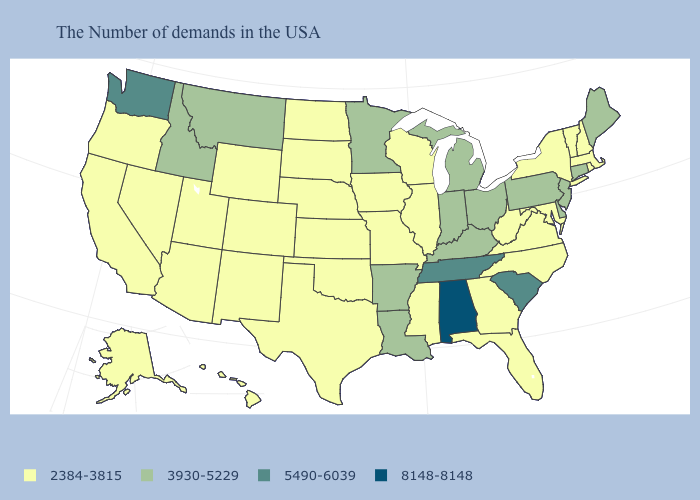What is the lowest value in the USA?
Short answer required. 2384-3815. What is the lowest value in states that border Idaho?
Concise answer only. 2384-3815. What is the value of South Dakota?
Concise answer only. 2384-3815. Name the states that have a value in the range 2384-3815?
Give a very brief answer. Massachusetts, Rhode Island, New Hampshire, Vermont, New York, Maryland, Virginia, North Carolina, West Virginia, Florida, Georgia, Wisconsin, Illinois, Mississippi, Missouri, Iowa, Kansas, Nebraska, Oklahoma, Texas, South Dakota, North Dakota, Wyoming, Colorado, New Mexico, Utah, Arizona, Nevada, California, Oregon, Alaska, Hawaii. What is the value of New Hampshire?
Keep it brief. 2384-3815. What is the lowest value in states that border Minnesota?
Short answer required. 2384-3815. Which states have the highest value in the USA?
Concise answer only. Alabama. Does Ohio have a higher value than Delaware?
Answer briefly. No. What is the lowest value in the USA?
Write a very short answer. 2384-3815. Does New Jersey have the lowest value in the Northeast?
Keep it brief. No. Does the first symbol in the legend represent the smallest category?
Keep it brief. Yes. What is the highest value in the USA?
Quick response, please. 8148-8148. Which states hav the highest value in the South?
Give a very brief answer. Alabama. What is the value of Wyoming?
Write a very short answer. 2384-3815. 